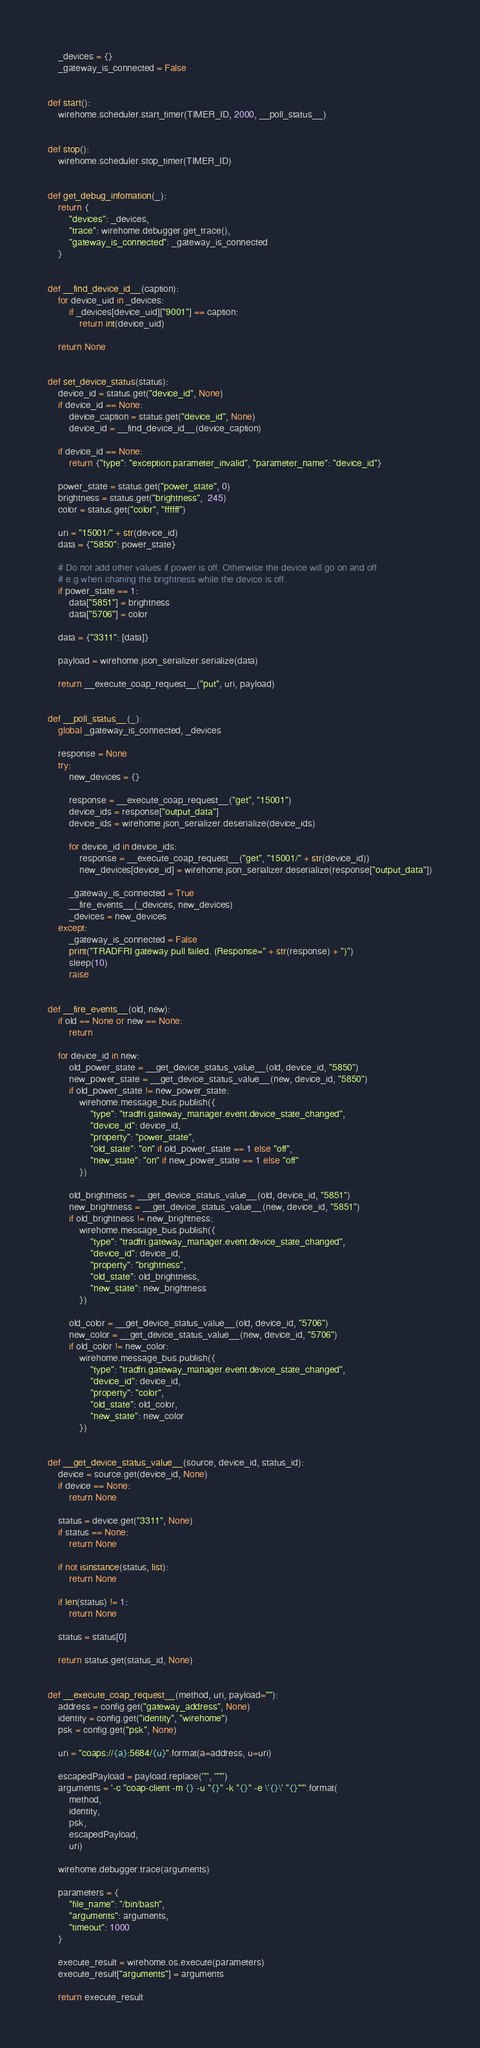<code> <loc_0><loc_0><loc_500><loc_500><_Python_>    _devices = {}
    _gateway_is_connected = False


def start():
    wirehome.scheduler.start_timer(TIMER_ID, 2000, __poll_status__)


def stop():
    wirehome.scheduler.stop_timer(TIMER_ID)


def get_debug_infomation(_):
    return {
        "devices": _devices,
        "trace": wirehome.debugger.get_trace(),
        "gateway_is_connected": _gateway_is_connected
    }


def __find_device_id__(caption):
    for device_uid in _devices:
        if _devices[device_uid]["9001"] == caption:
            return int(device_uid)

    return None


def set_device_status(status):
    device_id = status.get("device_id", None)
    if device_id == None:
        device_caption = status.get("device_id", None)
        device_id = __find_device_id__(device_caption)

    if device_id == None:
        return {"type": "exception.parameter_invalid", "parameter_name": "device_id"}

    power_state = status.get("power_state", 0)
    brightness = status.get("brightness",  245)
    color = status.get("color", "ffffff")

    uri = "15001/" + str(device_id)
    data = {"5850": power_state}

    # Do not add other values if power is off. Otherwise the device will go on and off
    # e.g when chaning the brightness while the device is off.
    if power_state == 1:
        data["5851"] = brightness
        data["5706"] = color

    data = {"3311": [data]}

    payload = wirehome.json_serializer.serialize(data)

    return __execute_coap_request__("put", uri, payload)


def __poll_status__(_):
    global _gateway_is_connected, _devices

    response = None
    try:
        new_devices = {}

        response = __execute_coap_request__("get", "15001")
        device_ids = response["output_data"]
        device_ids = wirehome.json_serializer.deserialize(device_ids)

        for device_id in device_ids:
            response = __execute_coap_request__("get", "15001/" + str(device_id))
            new_devices[device_id] = wirehome.json_serializer.deserialize(response["output_data"])

        _gateway_is_connected = True
        __fire_events__(_devices, new_devices)
        _devices = new_devices
    except:
        _gateway_is_connected = False
        print("TRADFRI gateway pull failed. (Response=" + str(response) + ")")
        sleep(10)
        raise


def __fire_events__(old, new):
    if old == None or new == None:
        return

    for device_id in new:
        old_power_state = __get_device_status_value__(old, device_id, "5850")
        new_power_state = __get_device_status_value__(new, device_id, "5850")
        if old_power_state != new_power_state:
            wirehome.message_bus.publish({
                "type": "tradfri.gateway_manager.event.device_state_changed",
                "device_id": device_id,
                "property": "power_state",
                "old_state": "on" if old_power_state == 1 else "off",
                "new_state": "on" if new_power_state == 1 else "off"
            })

        old_brightness = __get_device_status_value__(old, device_id, "5851")
        new_brightness = __get_device_status_value__(new, device_id, "5851")
        if old_brightness != new_brightness:
            wirehome.message_bus.publish({
                "type": "tradfri.gateway_manager.event.device_state_changed",
                "device_id": device_id,
                "property": "brightness",
                "old_state": old_brightness,
                "new_state": new_brightness
            })

        old_color = __get_device_status_value__(old, device_id, "5706")
        new_color = __get_device_status_value__(new, device_id, "5706")
        if old_color != new_color:
            wirehome.message_bus.publish({
                "type": "tradfri.gateway_manager.event.device_state_changed",
                "device_id": device_id,
                "property": "color",
                "old_state": old_color,
                "new_state": new_color
            })


def __get_device_status_value__(source, device_id, status_id):
    device = source.get(device_id, None)
    if device == None:
        return None

    status = device.get("3311", None)
    if status == None:
        return None

    if not isinstance(status, list):
        return None

    if len(status) != 1:
        return None

    status = status[0]

    return status.get(status_id, None)


def __execute_coap_request__(method, uri, payload=""):
    address = config.get("gateway_address", None)
    identity = config.get("identity", "wirehome")
    psk = config.get("psk", None)

    uri = "coaps://{a}:5684/{u}".format(a=address, u=uri)

    escapedPayload = payload.replace('"', '""')
    arguments = '-c "coap-client -m {} -u "{}" -k "{}" -e \'{}\' "{}""'.format(
        method,
        identity,
        psk,
        escapedPayload,
        uri)

    wirehome.debugger.trace(arguments)

    parameters = {
        "file_name": "/bin/bash",
        "arguments": arguments,
        "timeout": 1000
    }

    execute_result = wirehome.os.execute(parameters)
    execute_result["arguments"] = arguments

    return execute_result
</code> 